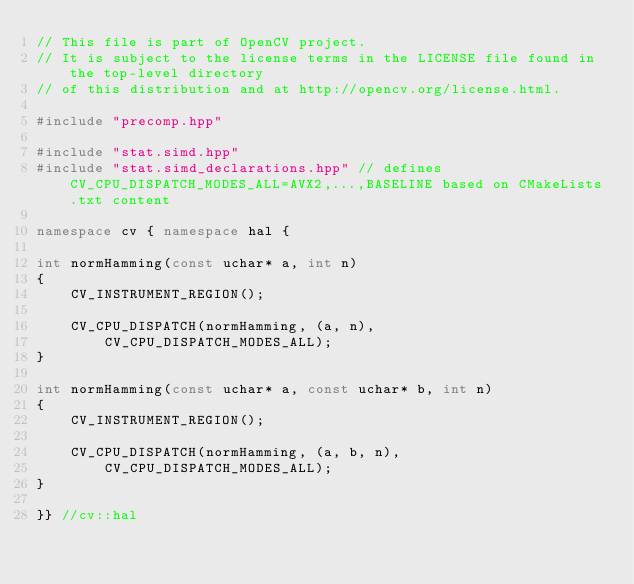<code> <loc_0><loc_0><loc_500><loc_500><_C++_>// This file is part of OpenCV project.
// It is subject to the license terms in the LICENSE file found in the top-level directory
// of this distribution and at http://opencv.org/license.html.

#include "precomp.hpp"

#include "stat.simd.hpp"
#include "stat.simd_declarations.hpp" // defines CV_CPU_DISPATCH_MODES_ALL=AVX2,...,BASELINE based on CMakeLists.txt content

namespace cv { namespace hal {

int normHamming(const uchar* a, int n)
{
    CV_INSTRUMENT_REGION();

    CV_CPU_DISPATCH(normHamming, (a, n),
        CV_CPU_DISPATCH_MODES_ALL);
}

int normHamming(const uchar* a, const uchar* b, int n)
{
    CV_INSTRUMENT_REGION();

    CV_CPU_DISPATCH(normHamming, (a, b, n),
        CV_CPU_DISPATCH_MODES_ALL);
}

}} //cv::hal
</code> 